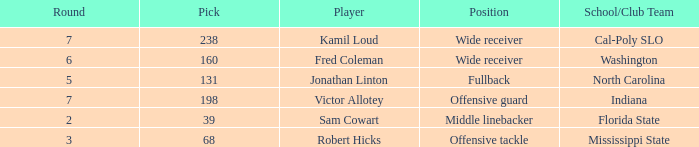Which Round has a School/Club Team of cal-poly slo, and a Pick smaller than 238? None. 